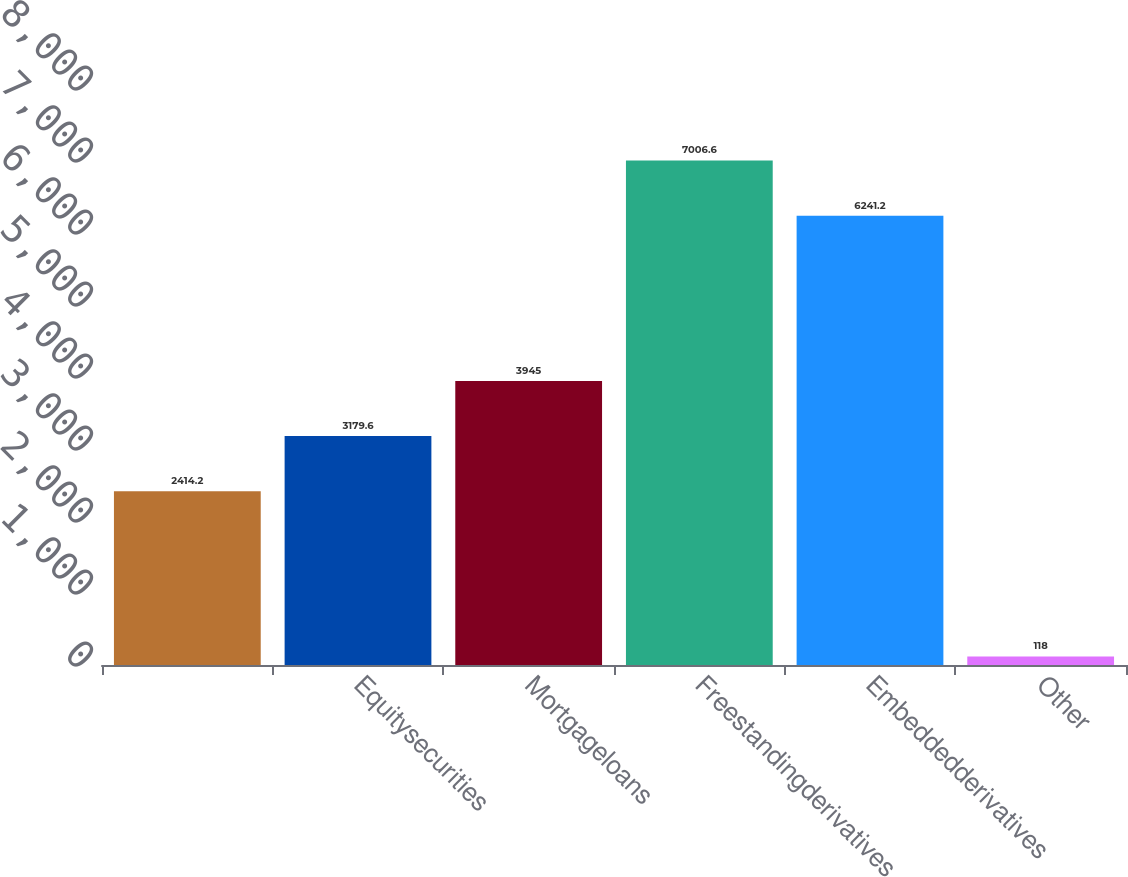<chart> <loc_0><loc_0><loc_500><loc_500><bar_chart><ecel><fcel>Equitysecurities<fcel>Mortgageloans<fcel>Freestandingderivatives<fcel>Embeddedderivatives<fcel>Other<nl><fcel>2414.2<fcel>3179.6<fcel>3945<fcel>7006.6<fcel>6241.2<fcel>118<nl></chart> 